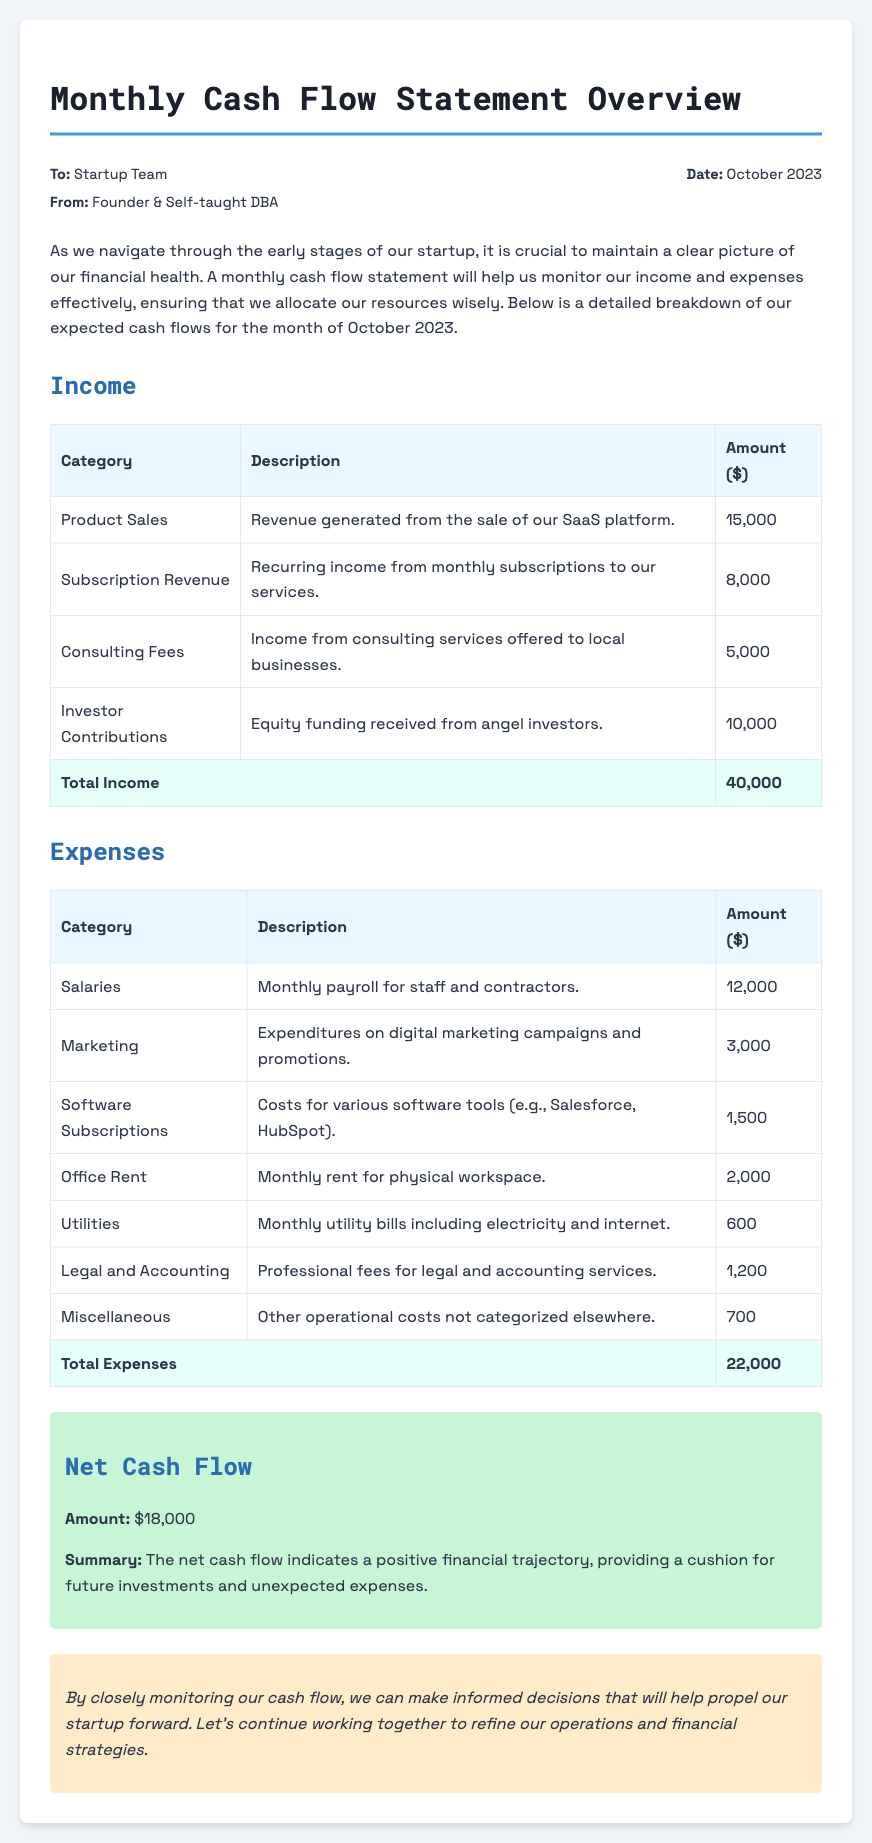what is the date of the memo? The date of the memo is stated in the document header as October 2023.
Answer: October 2023 what is the total income? The total income is summarized in the income section as the sum of all income categories, which is $15,000 + $8,000 + $5,000 + $10,000.
Answer: 40,000 how much is allocated for salaries? The document specifies that salaries account for a monthly payroll expense of $12,000.
Answer: 12,000 what is the net cash flow amount? The net cash flow is clearly stated in the net cash flow section as the difference between total income and total expenses.
Answer: 18,000 what type of funding is mentioned under income? The document identifies that equity funding received from angel investors contributes to the income section.
Answer: Investor Contributions what are the total expenses? The total expenses are calculated as the sum of all expense categories listed in the document, which amounts to $22,000.
Answer: 22,000 which expense category has the highest amount? Upon reviewing the expenses, it is noted that salaries have the highest allocation compared to other categories.
Answer: Salaries who is the memo addressed to? The memo header identifies that it is addressed to the Startup Team.
Answer: Startup Team what is the purpose of the monthly cash flow statement? The document explains that the monthly cash flow statement helps monitor financial health and resource allocation effectively.
Answer: Monitor financial health 